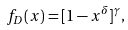<formula> <loc_0><loc_0><loc_500><loc_500>f _ { D } ( x ) = [ 1 - x ^ { \delta } ] ^ { \gamma } ,</formula> 